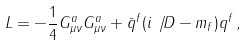Convert formula to latex. <formula><loc_0><loc_0><loc_500><loc_500>L = - \frac { 1 } { 4 } G ^ { a } _ { \mu \nu } G ^ { a } _ { \mu \nu } + \bar { q } ^ { f } ( i \not \, { D } - m _ { f } ) q ^ { f } \, ,</formula> 